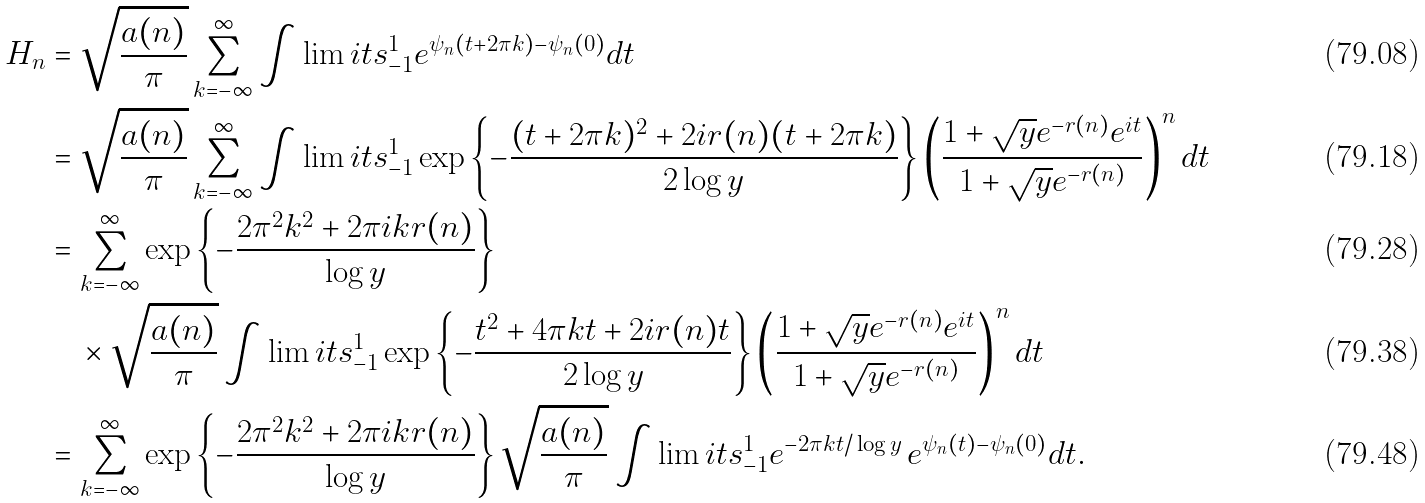<formula> <loc_0><loc_0><loc_500><loc_500>H _ { n } & = \sqrt { \frac { a ( n ) } { \pi } } \sum _ { k = - \infty } ^ { \infty } \int \lim i t s _ { - 1 } ^ { 1 } e ^ { \psi _ { n } ( t + 2 \pi k ) - \psi _ { n } ( 0 ) } d t \\ & = \sqrt { \frac { a ( n ) } { \pi } } \sum _ { k = - \infty } ^ { \infty } \int \lim i t s _ { - 1 } ^ { 1 } \exp \left \{ - \frac { ( t + 2 \pi k ) ^ { 2 } + 2 i r ( n ) ( t + 2 \pi k ) } { 2 \log y } \right \} \left ( \frac { 1 + \sqrt { y } e ^ { - r ( n ) } e ^ { i t } } { 1 + \sqrt { y } e ^ { - r ( n ) } } \right ) ^ { n } d t \\ & = \sum _ { k = - \infty } ^ { \infty } \exp \left \{ - \frac { 2 \pi ^ { 2 } k ^ { 2 } + 2 \pi i k r ( n ) } { \log y } \right \} \\ & \quad \times \sqrt { \frac { a ( n ) } { \pi } } \int \lim i t s _ { - 1 } ^ { 1 } \exp \left \{ - \frac { t ^ { 2 } + 4 \pi k t + 2 i r ( n ) t } { 2 \log y } \right \} \left ( \frac { 1 + \sqrt { y } e ^ { - r ( n ) } e ^ { i t } } { 1 + \sqrt { y } e ^ { - r ( n ) } } \right ) ^ { n } d t \\ & = \sum _ { k = - \infty } ^ { \infty } \exp \left \{ - \frac { 2 \pi ^ { 2 } k ^ { 2 } + 2 \pi i k r ( n ) } { \log y } \right \} \sqrt { \frac { a ( n ) } { \pi } } \int \lim i t s _ { - 1 } ^ { 1 } e ^ { - 2 \pi k t / \log y } \, e ^ { \psi _ { n } ( t ) - \psi _ { n } ( 0 ) } d t .</formula> 